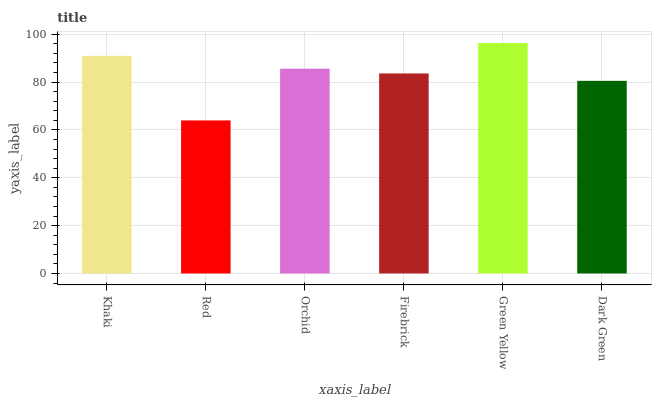Is Orchid the minimum?
Answer yes or no. No. Is Orchid the maximum?
Answer yes or no. No. Is Orchid greater than Red?
Answer yes or no. Yes. Is Red less than Orchid?
Answer yes or no. Yes. Is Red greater than Orchid?
Answer yes or no. No. Is Orchid less than Red?
Answer yes or no. No. Is Orchid the high median?
Answer yes or no. Yes. Is Firebrick the low median?
Answer yes or no. Yes. Is Khaki the high median?
Answer yes or no. No. Is Orchid the low median?
Answer yes or no. No. 